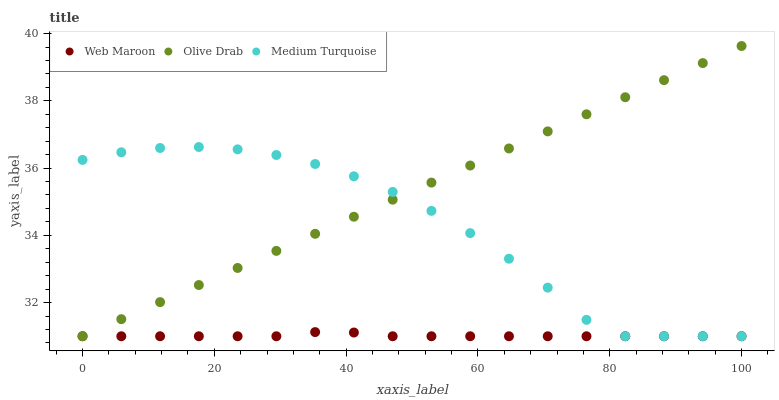Does Web Maroon have the minimum area under the curve?
Answer yes or no. Yes. Does Olive Drab have the maximum area under the curve?
Answer yes or no. Yes. Does Medium Turquoise have the minimum area under the curve?
Answer yes or no. No. Does Medium Turquoise have the maximum area under the curve?
Answer yes or no. No. Is Olive Drab the smoothest?
Answer yes or no. Yes. Is Medium Turquoise the roughest?
Answer yes or no. Yes. Is Medium Turquoise the smoothest?
Answer yes or no. No. Is Olive Drab the roughest?
Answer yes or no. No. Does Web Maroon have the lowest value?
Answer yes or no. Yes. Does Olive Drab have the highest value?
Answer yes or no. Yes. Does Medium Turquoise have the highest value?
Answer yes or no. No. Does Medium Turquoise intersect Web Maroon?
Answer yes or no. Yes. Is Medium Turquoise less than Web Maroon?
Answer yes or no. No. Is Medium Turquoise greater than Web Maroon?
Answer yes or no. No. 